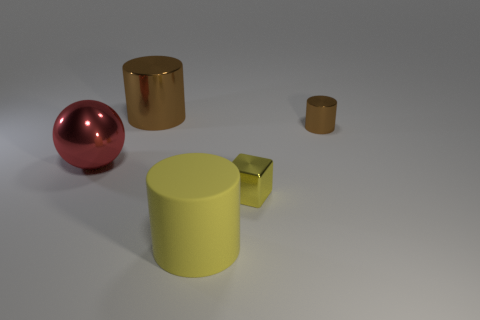Subtract all large brown metallic cylinders. How many cylinders are left? 2 Subtract all cyan balls. How many brown cylinders are left? 2 Add 2 large yellow cylinders. How many objects exist? 7 Subtract all cylinders. How many objects are left? 2 Subtract all blue cylinders. Subtract all green balls. How many cylinders are left? 3 Add 2 large red objects. How many large red objects are left? 3 Add 3 small brown shiny cylinders. How many small brown shiny cylinders exist? 4 Subtract 0 yellow balls. How many objects are left? 5 Subtract all tiny blue shiny balls. Subtract all big yellow matte cylinders. How many objects are left? 4 